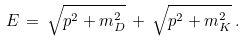Convert formula to latex. <formula><loc_0><loc_0><loc_500><loc_500>E \, = \, \sqrt { p ^ { 2 } + m ^ { 2 } _ { D } } \, + \, \sqrt { p ^ { 2 } + m ^ { 2 } _ { K } } \, .</formula> 